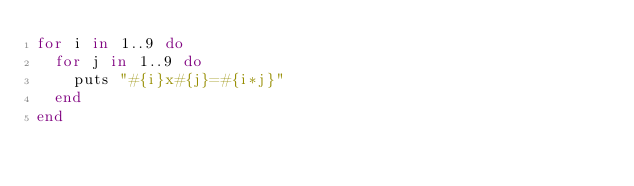Convert code to text. <code><loc_0><loc_0><loc_500><loc_500><_Ruby_>for i in 1..9 do
  for j in 1..9 do
    puts "#{i}x#{j}=#{i*j}"
  end
end

</code> 